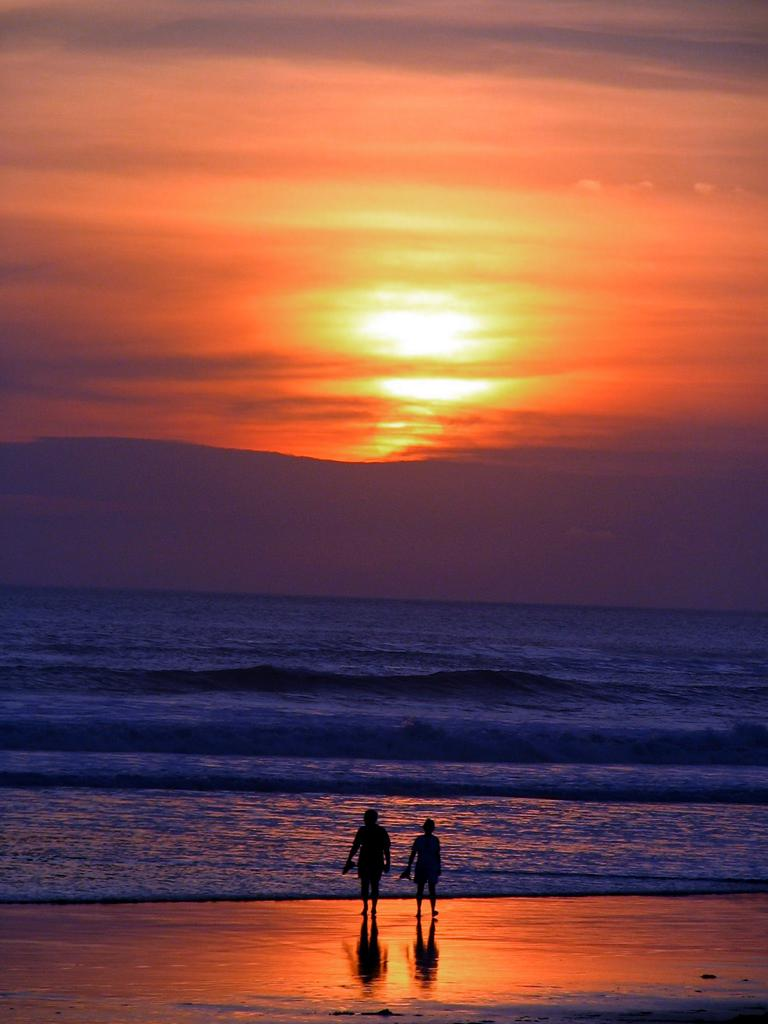How many people are in the image? There are two persons standing on the land. What is in front of the persons? There is water with tides in front of the persons. What can be seen at the top of the image? The sky is visible at the top of the image. What is the condition of the sky in the image? The sun is present in the sky. What type of pump can be seen in the image? There is no pump present in the image. What game are the persons playing in the image? There is no game being played in the image; the persons are simply standing on the land. 